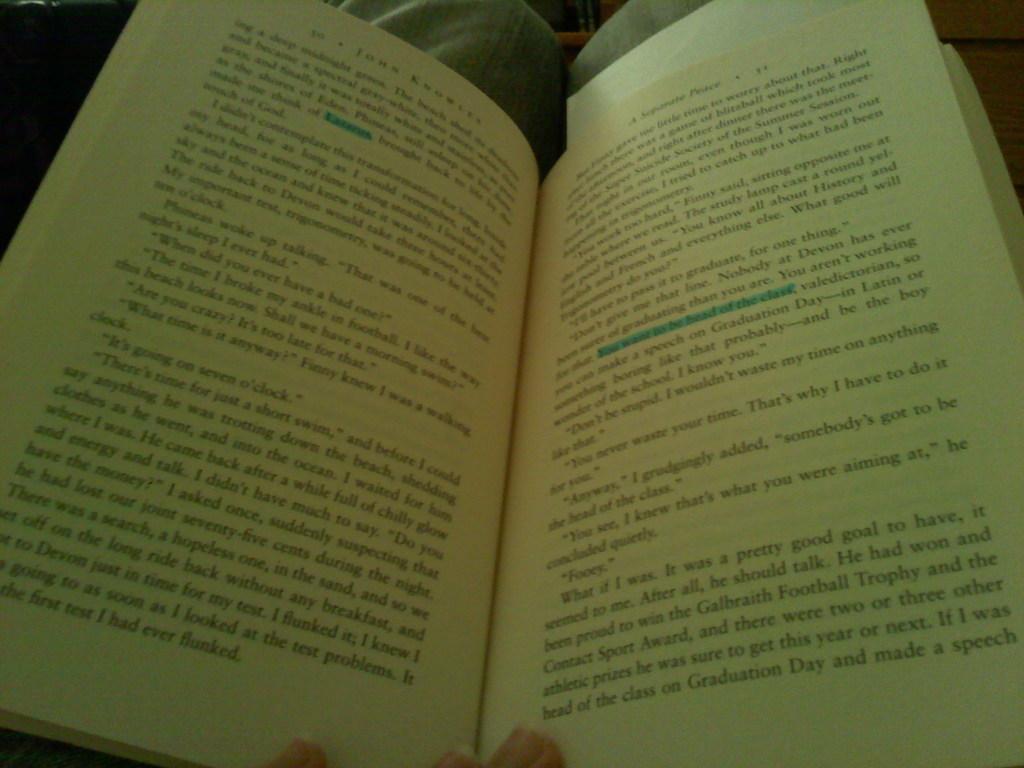Who is the author of this book?
Give a very brief answer. John knowles. What special event is mentioned in the last line?
Make the answer very short. Graduation day. 